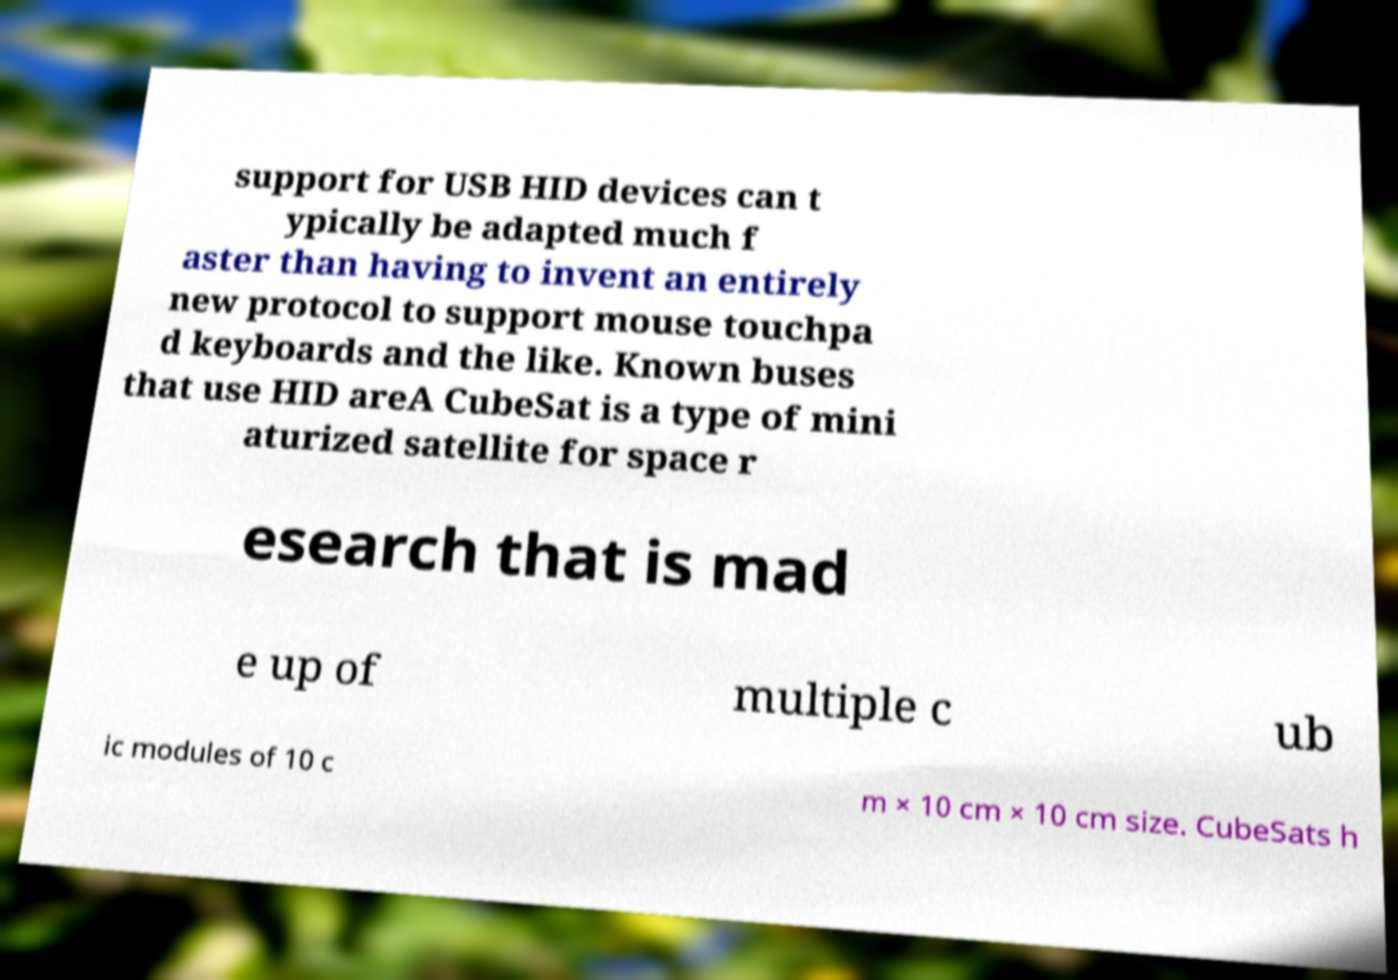For documentation purposes, I need the text within this image transcribed. Could you provide that? support for USB HID devices can t ypically be adapted much f aster than having to invent an entirely new protocol to support mouse touchpa d keyboards and the like. Known buses that use HID areA CubeSat is a type of mini aturized satellite for space r esearch that is mad e up of multiple c ub ic modules of 10 c m × 10 cm × 10 cm size. CubeSats h 